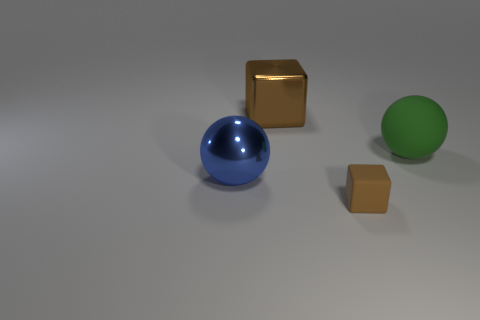Are there any other things that have the same color as the metal block?
Your answer should be compact. Yes. Do the big shiny block and the shiny object that is in front of the big green rubber object have the same color?
Provide a short and direct response. No. Are there fewer balls that are on the right side of the large green rubber ball than small blue matte cylinders?
Provide a short and direct response. No. There is a brown object that is behind the small brown thing; what material is it?
Provide a short and direct response. Metal. How many other things are the same size as the rubber cube?
Offer a very short reply. 0. Is the size of the shiny block the same as the ball that is on the right side of the blue metal ball?
Keep it short and to the point. Yes. What shape is the shiny thing that is left of the big thing behind the green rubber object that is to the right of the small matte block?
Offer a very short reply. Sphere. Is the number of big brown cubes less than the number of balls?
Give a very brief answer. Yes. There is a brown shiny thing; are there any large green matte objects in front of it?
Make the answer very short. Yes. The object that is behind the tiny block and in front of the large green sphere has what shape?
Make the answer very short. Sphere. 